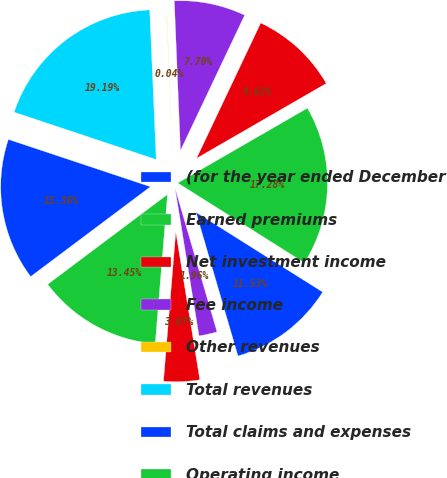Convert chart to OTSL. <chart><loc_0><loc_0><loc_500><loc_500><pie_chart><fcel>(for the year ended December<fcel>Earned premiums<fcel>Net investment income<fcel>Fee income<fcel>Other revenues<fcel>Total revenues<fcel>Total claims and expenses<fcel>Operating income<fcel>Loss and loss adjustment<fcel>Underwriting expense ratio<nl><fcel>11.53%<fcel>17.28%<fcel>9.62%<fcel>7.7%<fcel>0.04%<fcel>19.19%<fcel>15.36%<fcel>13.45%<fcel>3.87%<fcel>1.96%<nl></chart> 